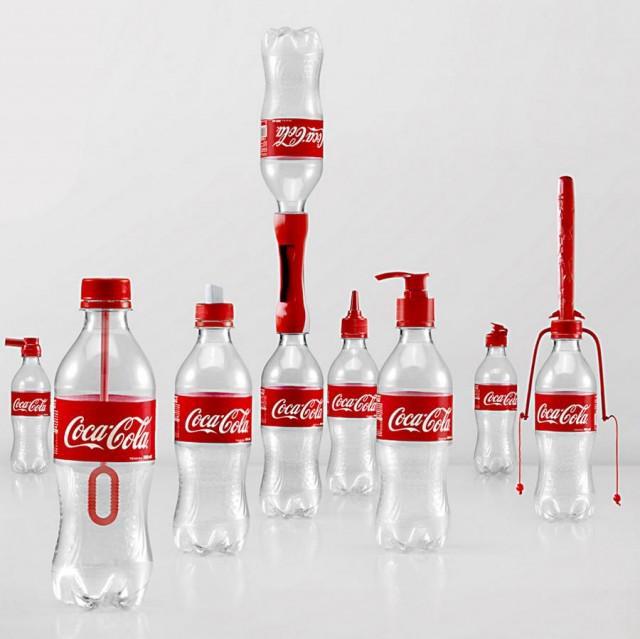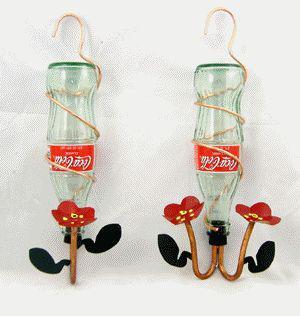The first image is the image on the left, the second image is the image on the right. Considering the images on both sides, is "There is no more than three bottles in the right image." valid? Answer yes or no. Yes. 